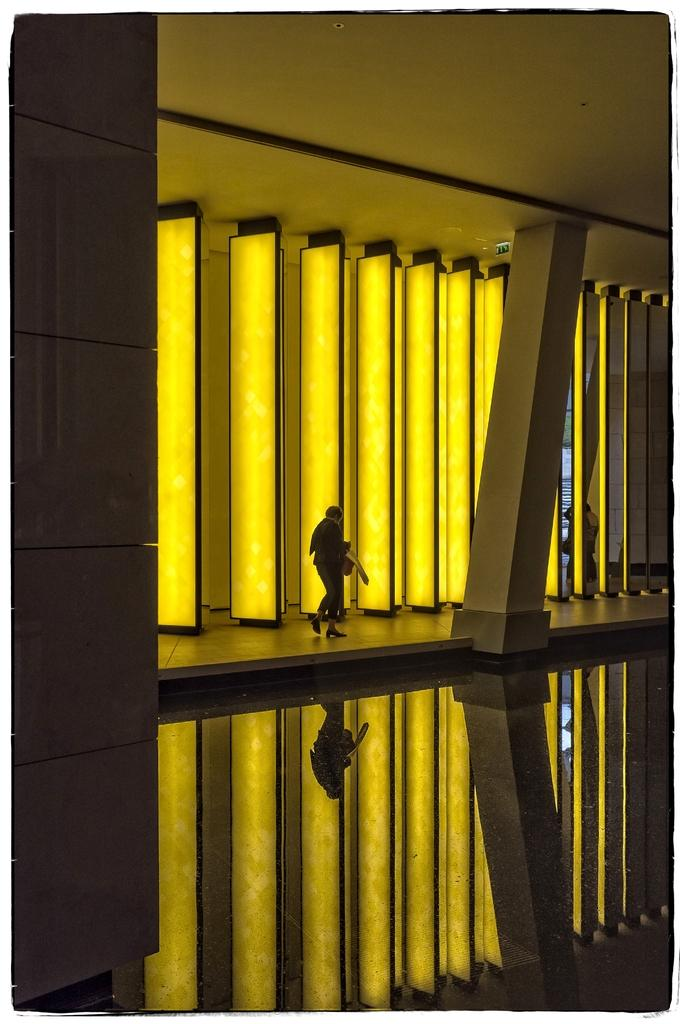What is the main subject of the image? There is a person standing in the image. Where is the person standing in relation to the roof? The person is standing under a roof. What can be seen in the background of the image? There are light poles in the background of the image. How many girls are sitting on the wall in the image? There is no wall or girl present in the image. 